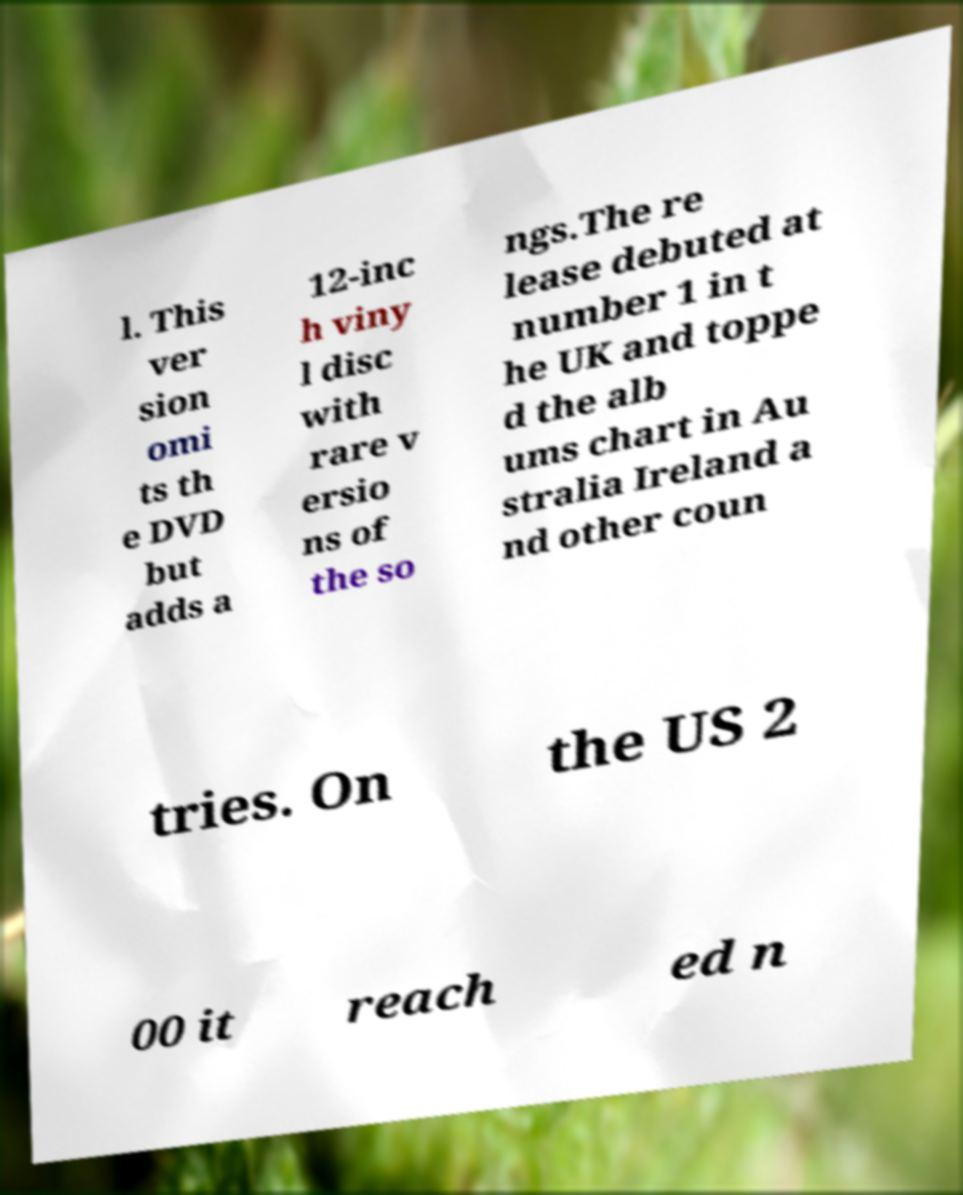What messages or text are displayed in this image? I need them in a readable, typed format. l. This ver sion omi ts th e DVD but adds a 12-inc h viny l disc with rare v ersio ns of the so ngs.The re lease debuted at number 1 in t he UK and toppe d the alb ums chart in Au stralia Ireland a nd other coun tries. On the US 2 00 it reach ed n 